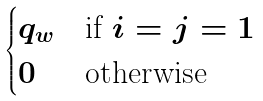<formula> <loc_0><loc_0><loc_500><loc_500>\begin{cases} q _ { w } & \text {if $i=j=1$} \\ 0 & \text {otherwise} \end{cases}</formula> 